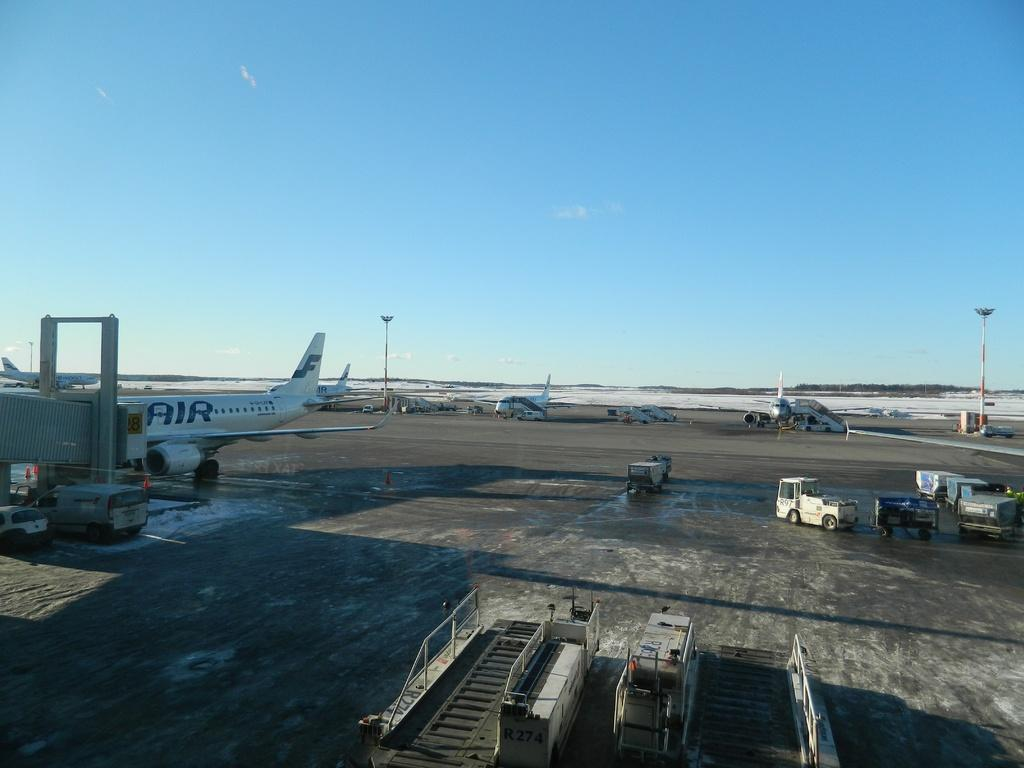What types of transportation are visible in the image? There are vehicles and aircraft in the image. What structures can be seen in the image? There are light poles in the image. What type of natural environment is visible in the background of the image? There are trees in the background of the image. What is the color of the sky in the image? The sky is blue in color. What direction is the magic stomach facing in the image? There is no magic stomach present in the image. 